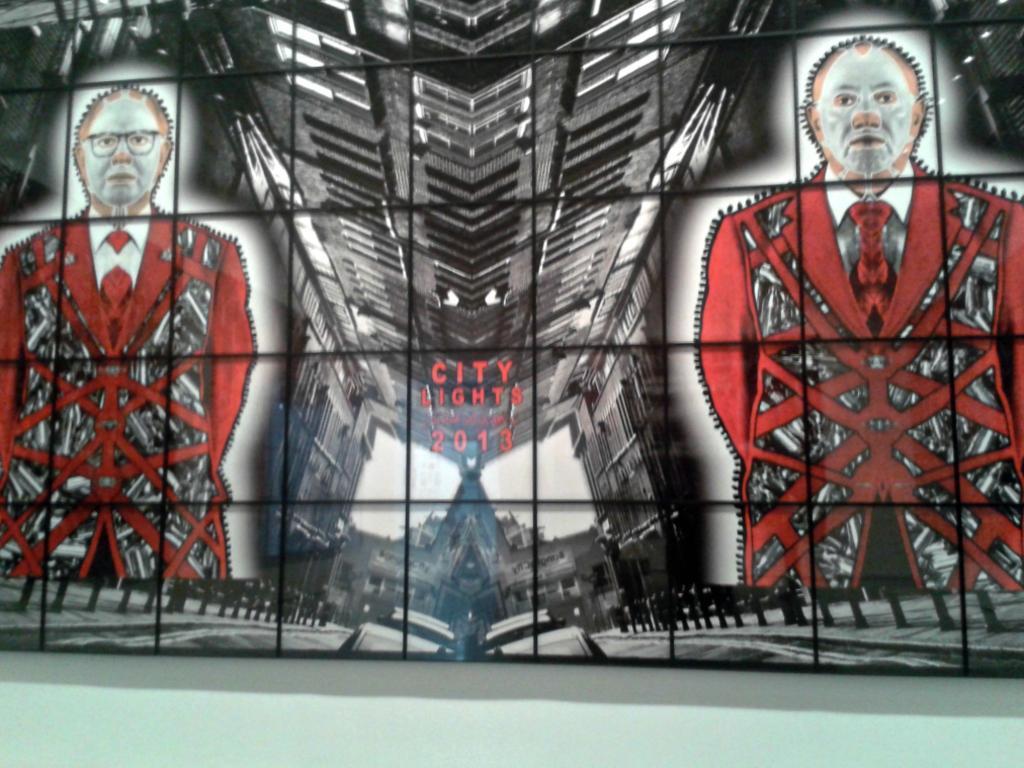Please provide a concise description of this image. In the picture we can see a glass wall on it we can see a image of some animation pictures and on it written as city lights 2013. 